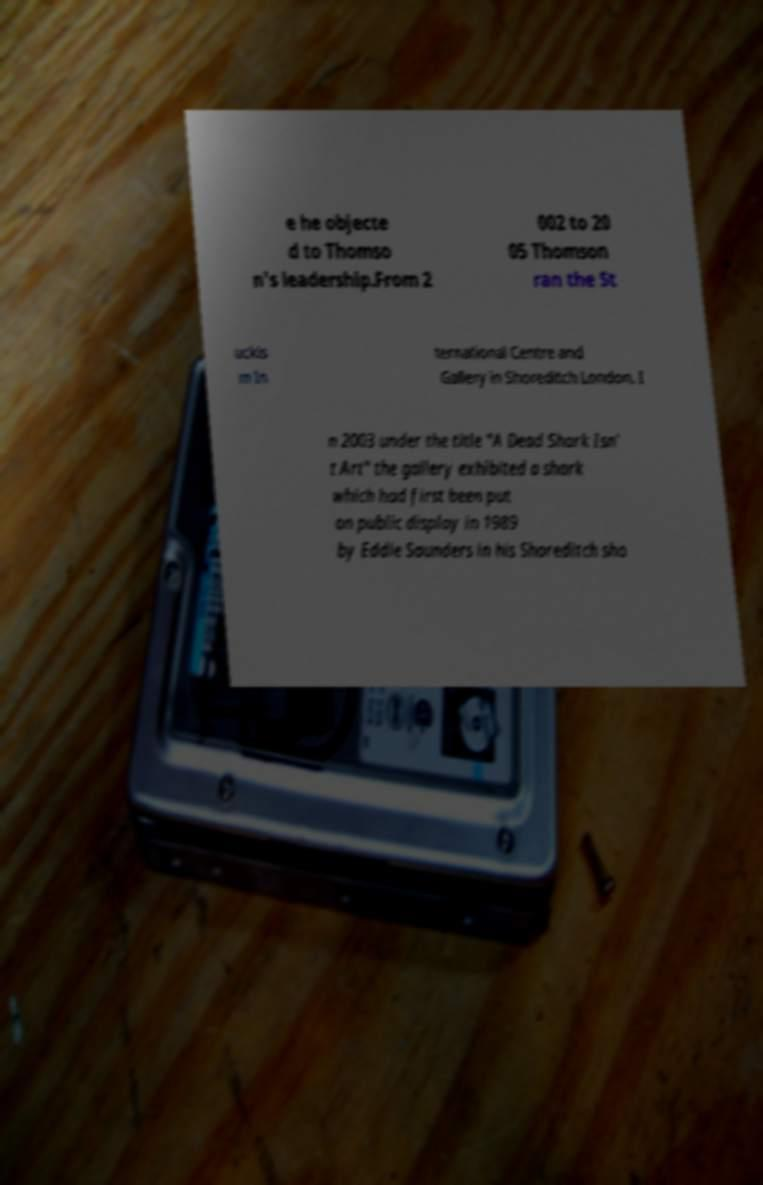There's text embedded in this image that I need extracted. Can you transcribe it verbatim? e he objecte d to Thomso n's leadership.From 2 002 to 20 05 Thomson ran the St uckis m In ternational Centre and Gallery in Shoreditch London. I n 2003 under the title "A Dead Shark Isn' t Art" the gallery exhibited a shark which had first been put on public display in 1989 by Eddie Saunders in his Shoreditch sho 